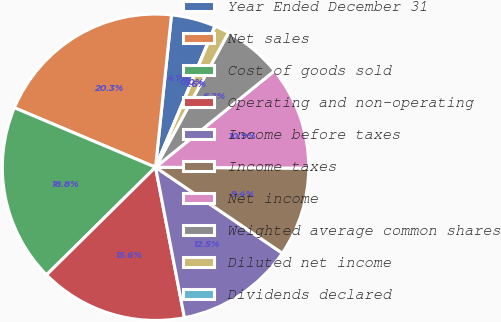<chart> <loc_0><loc_0><loc_500><loc_500><pie_chart><fcel>Year Ended December 31<fcel>Net sales<fcel>Cost of goods sold<fcel>Operating and non-operating<fcel>Income before taxes<fcel>Income taxes<fcel>Net income<fcel>Weighted average common shares<fcel>Diluted net income<fcel>Dividends declared<nl><fcel>4.69%<fcel>20.31%<fcel>18.75%<fcel>15.62%<fcel>12.5%<fcel>9.38%<fcel>10.94%<fcel>6.25%<fcel>1.56%<fcel>0.0%<nl></chart> 